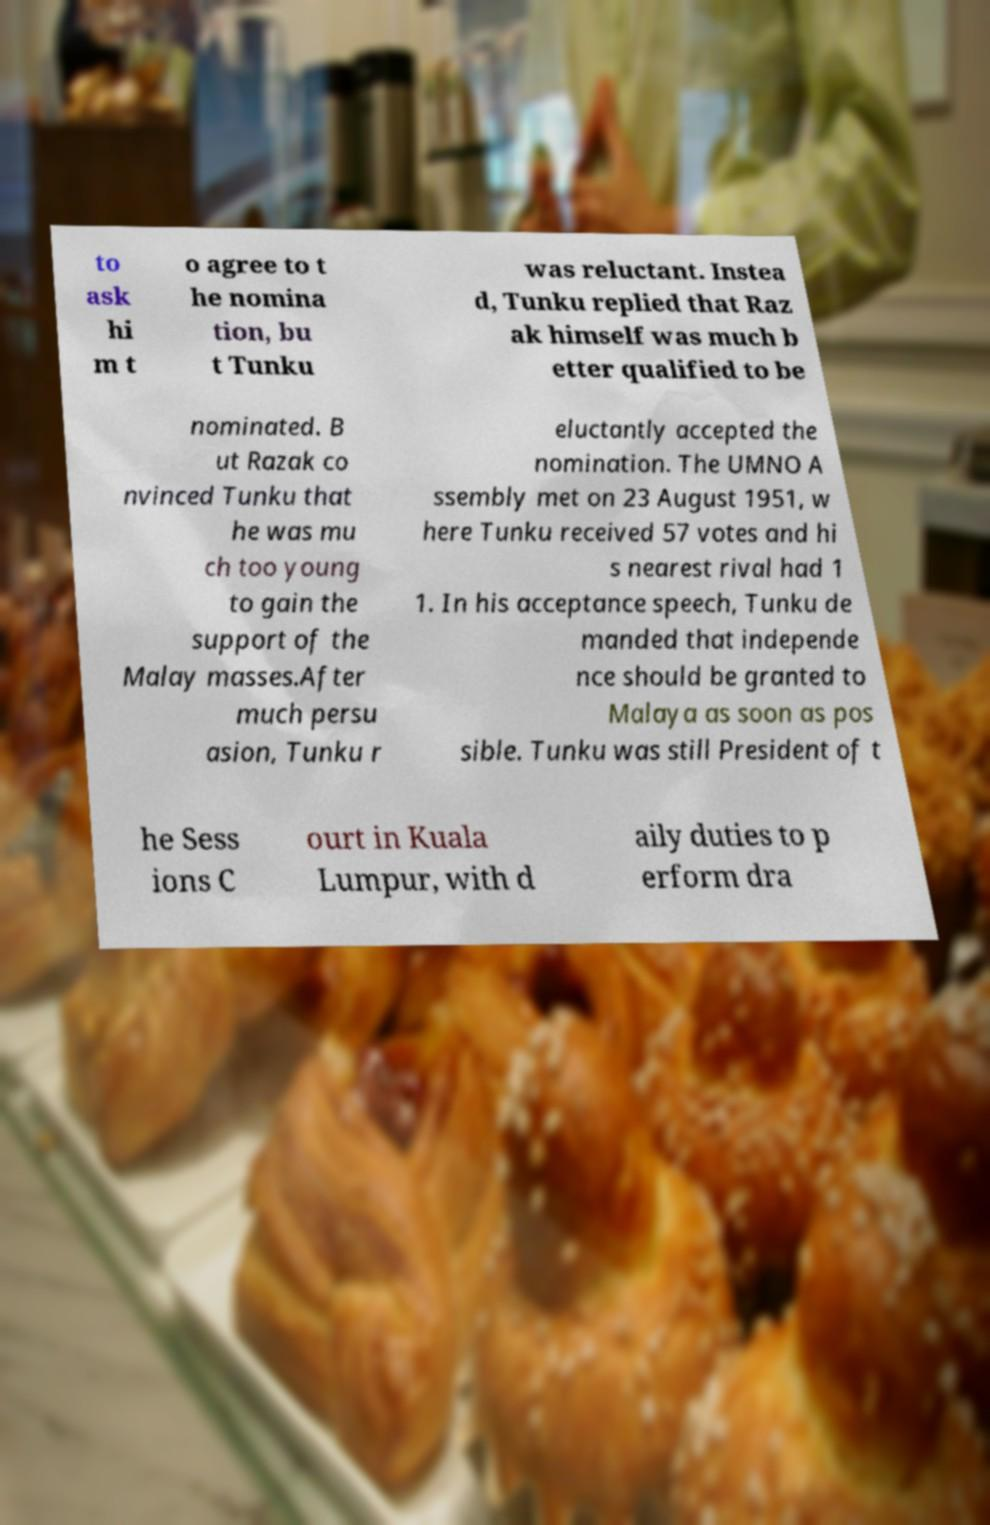What messages or text are displayed in this image? I need them in a readable, typed format. to ask hi m t o agree to t he nomina tion, bu t Tunku was reluctant. Instea d, Tunku replied that Raz ak himself was much b etter qualified to be nominated. B ut Razak co nvinced Tunku that he was mu ch too young to gain the support of the Malay masses.After much persu asion, Tunku r eluctantly accepted the nomination. The UMNO A ssembly met on 23 August 1951, w here Tunku received 57 votes and hi s nearest rival had 1 1. In his acceptance speech, Tunku de manded that independe nce should be granted to Malaya as soon as pos sible. Tunku was still President of t he Sess ions C ourt in Kuala Lumpur, with d aily duties to p erform dra 